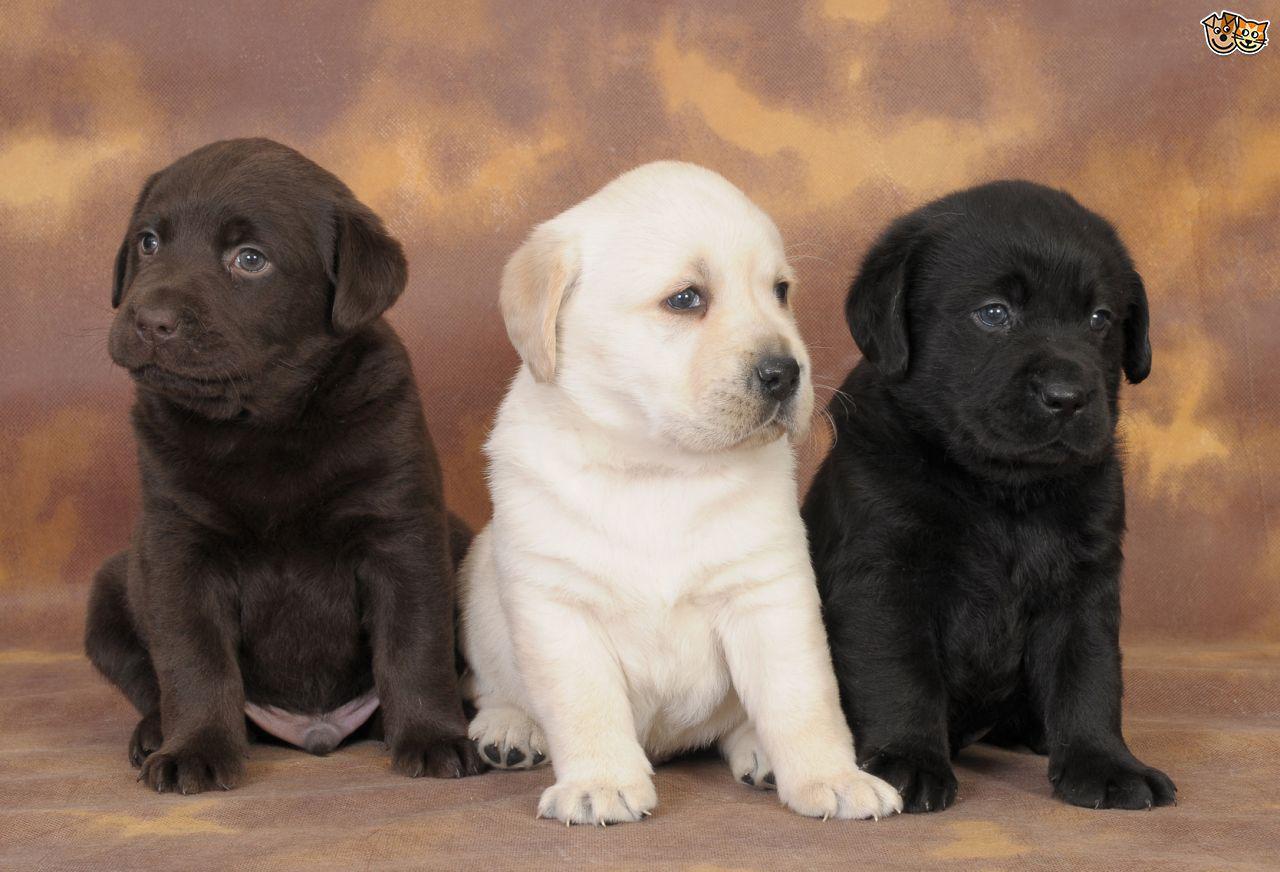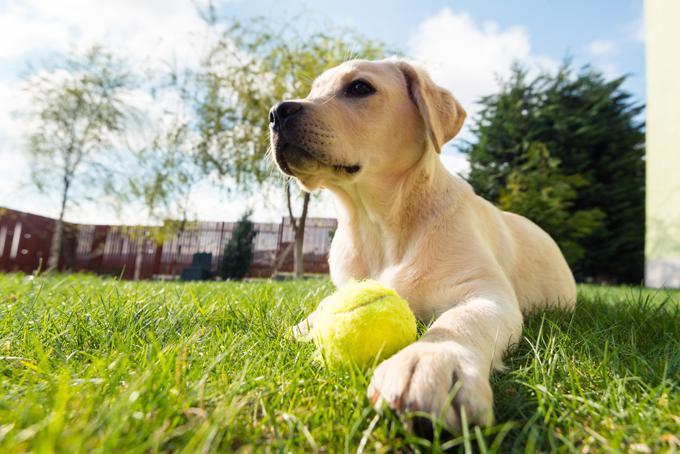The first image is the image on the left, the second image is the image on the right. Examine the images to the left and right. Is the description "one of the dogs is showing its teeth" accurate? Answer yes or no. No. The first image is the image on the left, the second image is the image on the right. Evaluate the accuracy of this statement regarding the images: "There are exactly two young puppies in each set of images.". Is it true? Answer yes or no. No. The first image is the image on the left, the second image is the image on the right. Given the left and right images, does the statement "One of the images shows a dog with a dog toy in their possession." hold true? Answer yes or no. Yes. 